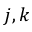<formula> <loc_0><loc_0><loc_500><loc_500>j , k</formula> 